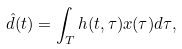<formula> <loc_0><loc_0><loc_500><loc_500>\hat { d } ( t ) = \int _ { T } h ( t , \tau ) x ( \tau ) d \tau ,</formula> 